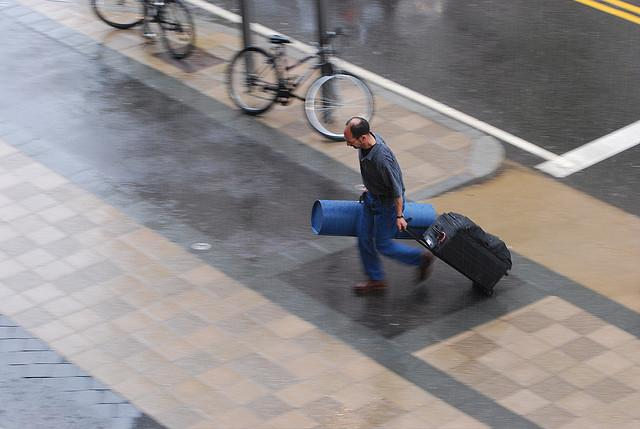What is the man transporting? Please explain your reasoning. luggage. The man is moving bags, not food. 